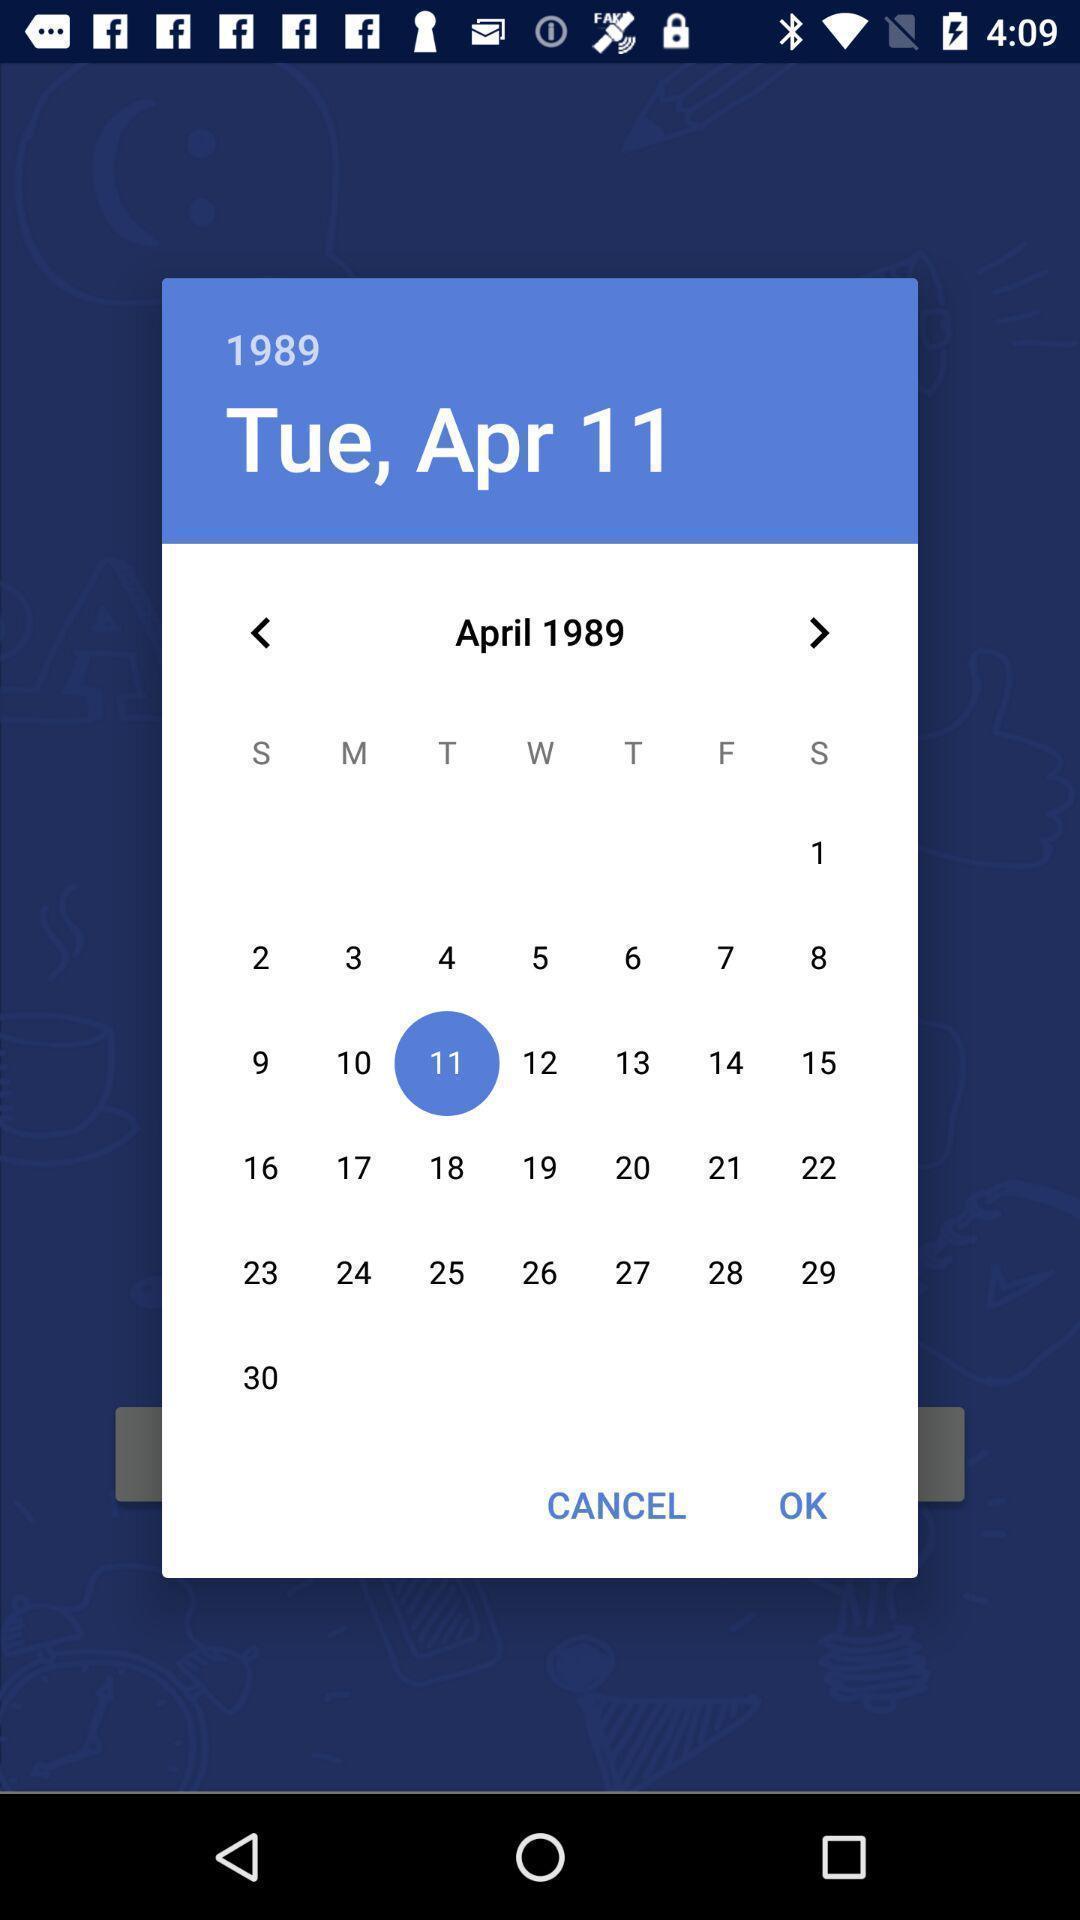Provide a detailed account of this screenshot. Pop-up page displaying with calendar to set the date. 